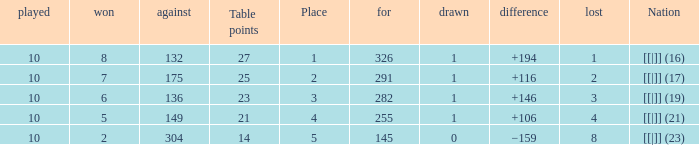 How many table points are listed for the deficit is +194?  1.0. 